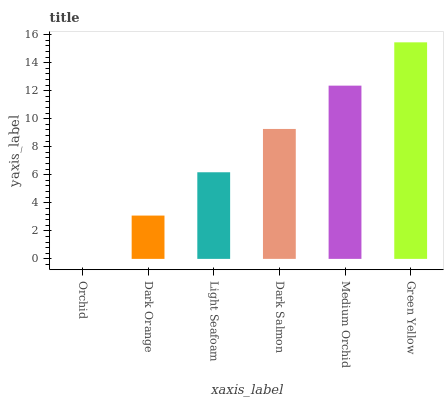Is Orchid the minimum?
Answer yes or no. Yes. Is Green Yellow the maximum?
Answer yes or no. Yes. Is Dark Orange the minimum?
Answer yes or no. No. Is Dark Orange the maximum?
Answer yes or no. No. Is Dark Orange greater than Orchid?
Answer yes or no. Yes. Is Orchid less than Dark Orange?
Answer yes or no. Yes. Is Orchid greater than Dark Orange?
Answer yes or no. No. Is Dark Orange less than Orchid?
Answer yes or no. No. Is Dark Salmon the high median?
Answer yes or no. Yes. Is Light Seafoam the low median?
Answer yes or no. Yes. Is Medium Orchid the high median?
Answer yes or no. No. Is Green Yellow the low median?
Answer yes or no. No. 